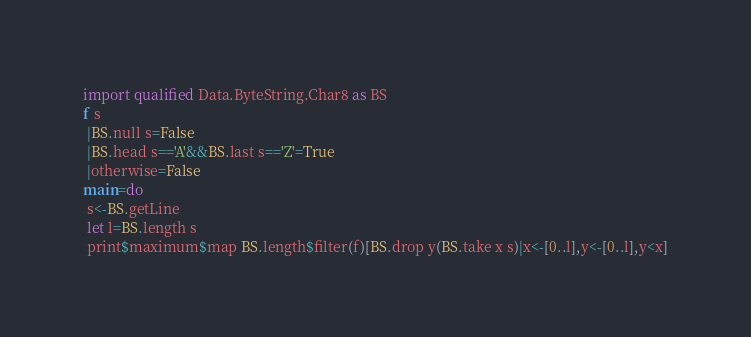Convert code to text. <code><loc_0><loc_0><loc_500><loc_500><_Haskell_>import qualified Data.ByteString.Char8 as BS
f s
 |BS.null s=False
 |BS.head s=='A'&&BS.last s=='Z'=True
 |otherwise=False
main=do
 s<-BS.getLine
 let l=BS.length s
 print$maximum$map BS.length$filter(f)[BS.drop y(BS.take x s)|x<-[0..l],y<-[0..l],y<x]</code> 